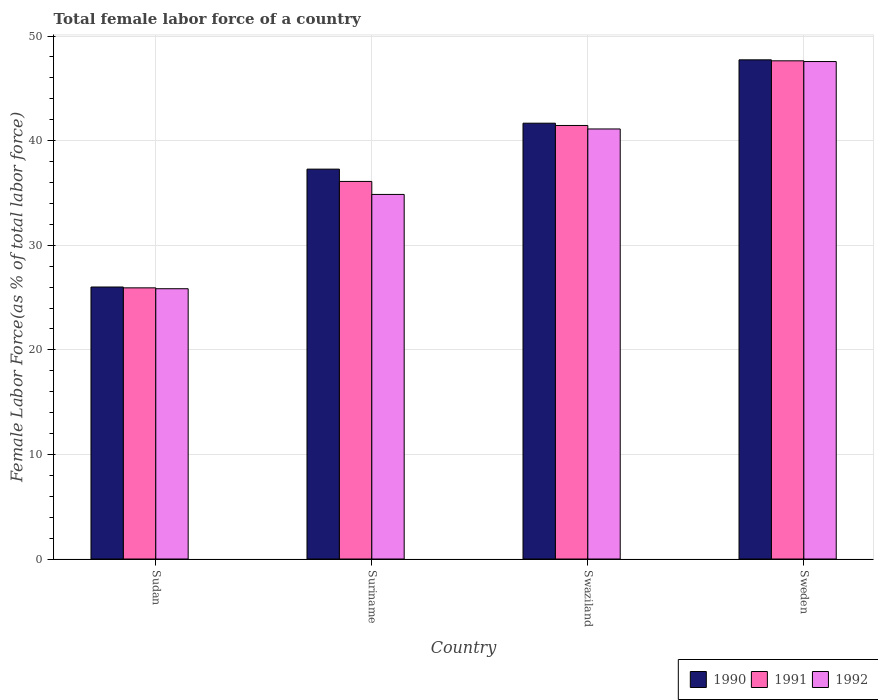How many different coloured bars are there?
Your answer should be very brief. 3. Are the number of bars per tick equal to the number of legend labels?
Your answer should be very brief. Yes. How many bars are there on the 4th tick from the right?
Provide a short and direct response. 3. In how many cases, is the number of bars for a given country not equal to the number of legend labels?
Make the answer very short. 0. What is the percentage of female labor force in 1991 in Swaziland?
Your answer should be compact. 41.45. Across all countries, what is the maximum percentage of female labor force in 1992?
Make the answer very short. 47.57. Across all countries, what is the minimum percentage of female labor force in 1990?
Give a very brief answer. 26.01. In which country was the percentage of female labor force in 1991 maximum?
Provide a short and direct response. Sweden. In which country was the percentage of female labor force in 1991 minimum?
Your answer should be compact. Sudan. What is the total percentage of female labor force in 1992 in the graph?
Your answer should be compact. 149.39. What is the difference between the percentage of female labor force in 1991 in Swaziland and that in Sweden?
Offer a terse response. -6.18. What is the difference between the percentage of female labor force in 1990 in Suriname and the percentage of female labor force in 1992 in Swaziland?
Give a very brief answer. -3.84. What is the average percentage of female labor force in 1990 per country?
Your answer should be compact. 38.17. What is the difference between the percentage of female labor force of/in 1991 and percentage of female labor force of/in 1990 in Swaziland?
Offer a very short reply. -0.22. In how many countries, is the percentage of female labor force in 1990 greater than 10 %?
Provide a succinct answer. 4. What is the ratio of the percentage of female labor force in 1991 in Suriname to that in Sweden?
Your answer should be compact. 0.76. What is the difference between the highest and the second highest percentage of female labor force in 1992?
Ensure brevity in your answer.  6.26. What is the difference between the highest and the lowest percentage of female labor force in 1991?
Ensure brevity in your answer.  21.71. Is the sum of the percentage of female labor force in 1992 in Sudan and Sweden greater than the maximum percentage of female labor force in 1990 across all countries?
Your answer should be compact. Yes. What does the 3rd bar from the left in Sudan represents?
Offer a very short reply. 1992. What does the 3rd bar from the right in Sudan represents?
Keep it short and to the point. 1990. How many bars are there?
Your answer should be very brief. 12. How many countries are there in the graph?
Offer a very short reply. 4. Are the values on the major ticks of Y-axis written in scientific E-notation?
Your answer should be compact. No. Does the graph contain any zero values?
Offer a very short reply. No. How are the legend labels stacked?
Offer a very short reply. Horizontal. What is the title of the graph?
Ensure brevity in your answer.  Total female labor force of a country. What is the label or title of the X-axis?
Your answer should be compact. Country. What is the label or title of the Y-axis?
Make the answer very short. Female Labor Force(as % of total labor force). What is the Female Labor Force(as % of total labor force) of 1990 in Sudan?
Your answer should be compact. 26.01. What is the Female Labor Force(as % of total labor force) in 1991 in Sudan?
Offer a terse response. 25.93. What is the Female Labor Force(as % of total labor force) in 1992 in Sudan?
Your answer should be compact. 25.84. What is the Female Labor Force(as % of total labor force) in 1990 in Suriname?
Your answer should be very brief. 37.28. What is the Female Labor Force(as % of total labor force) in 1991 in Suriname?
Provide a short and direct response. 36.1. What is the Female Labor Force(as % of total labor force) in 1992 in Suriname?
Ensure brevity in your answer.  34.86. What is the Female Labor Force(as % of total labor force) in 1990 in Swaziland?
Offer a terse response. 41.67. What is the Female Labor Force(as % of total labor force) in 1991 in Swaziland?
Provide a succinct answer. 41.45. What is the Female Labor Force(as % of total labor force) in 1992 in Swaziland?
Offer a very short reply. 41.12. What is the Female Labor Force(as % of total labor force) in 1990 in Sweden?
Your answer should be compact. 47.73. What is the Female Labor Force(as % of total labor force) in 1991 in Sweden?
Make the answer very short. 47.63. What is the Female Labor Force(as % of total labor force) of 1992 in Sweden?
Provide a short and direct response. 47.57. Across all countries, what is the maximum Female Labor Force(as % of total labor force) of 1990?
Your answer should be compact. 47.73. Across all countries, what is the maximum Female Labor Force(as % of total labor force) of 1991?
Provide a succinct answer. 47.63. Across all countries, what is the maximum Female Labor Force(as % of total labor force) in 1992?
Offer a terse response. 47.57. Across all countries, what is the minimum Female Labor Force(as % of total labor force) in 1990?
Your answer should be compact. 26.01. Across all countries, what is the minimum Female Labor Force(as % of total labor force) in 1991?
Your answer should be very brief. 25.93. Across all countries, what is the minimum Female Labor Force(as % of total labor force) of 1992?
Make the answer very short. 25.84. What is the total Female Labor Force(as % of total labor force) in 1990 in the graph?
Offer a terse response. 152.68. What is the total Female Labor Force(as % of total labor force) in 1991 in the graph?
Your response must be concise. 151.12. What is the total Female Labor Force(as % of total labor force) in 1992 in the graph?
Offer a terse response. 149.39. What is the difference between the Female Labor Force(as % of total labor force) of 1990 in Sudan and that in Suriname?
Make the answer very short. -11.27. What is the difference between the Female Labor Force(as % of total labor force) in 1991 in Sudan and that in Suriname?
Give a very brief answer. -10.17. What is the difference between the Female Labor Force(as % of total labor force) in 1992 in Sudan and that in Suriname?
Your answer should be compact. -9.02. What is the difference between the Female Labor Force(as % of total labor force) in 1990 in Sudan and that in Swaziland?
Provide a succinct answer. -15.66. What is the difference between the Female Labor Force(as % of total labor force) of 1991 in Sudan and that in Swaziland?
Keep it short and to the point. -15.53. What is the difference between the Female Labor Force(as % of total labor force) of 1992 in Sudan and that in Swaziland?
Give a very brief answer. -15.28. What is the difference between the Female Labor Force(as % of total labor force) of 1990 in Sudan and that in Sweden?
Offer a terse response. -21.72. What is the difference between the Female Labor Force(as % of total labor force) in 1991 in Sudan and that in Sweden?
Give a very brief answer. -21.71. What is the difference between the Female Labor Force(as % of total labor force) in 1992 in Sudan and that in Sweden?
Your response must be concise. -21.72. What is the difference between the Female Labor Force(as % of total labor force) of 1990 in Suriname and that in Swaziland?
Offer a terse response. -4.39. What is the difference between the Female Labor Force(as % of total labor force) of 1991 in Suriname and that in Swaziland?
Your response must be concise. -5.35. What is the difference between the Female Labor Force(as % of total labor force) of 1992 in Suriname and that in Swaziland?
Provide a short and direct response. -6.26. What is the difference between the Female Labor Force(as % of total labor force) in 1990 in Suriname and that in Sweden?
Ensure brevity in your answer.  -10.45. What is the difference between the Female Labor Force(as % of total labor force) in 1991 in Suriname and that in Sweden?
Give a very brief answer. -11.53. What is the difference between the Female Labor Force(as % of total labor force) in 1992 in Suriname and that in Sweden?
Offer a terse response. -12.71. What is the difference between the Female Labor Force(as % of total labor force) of 1990 in Swaziland and that in Sweden?
Provide a succinct answer. -6.06. What is the difference between the Female Labor Force(as % of total labor force) in 1991 in Swaziland and that in Sweden?
Your answer should be very brief. -6.18. What is the difference between the Female Labor Force(as % of total labor force) in 1992 in Swaziland and that in Sweden?
Your answer should be very brief. -6.45. What is the difference between the Female Labor Force(as % of total labor force) of 1990 in Sudan and the Female Labor Force(as % of total labor force) of 1991 in Suriname?
Offer a very short reply. -10.09. What is the difference between the Female Labor Force(as % of total labor force) in 1990 in Sudan and the Female Labor Force(as % of total labor force) in 1992 in Suriname?
Offer a terse response. -8.85. What is the difference between the Female Labor Force(as % of total labor force) in 1991 in Sudan and the Female Labor Force(as % of total labor force) in 1992 in Suriname?
Offer a terse response. -8.93. What is the difference between the Female Labor Force(as % of total labor force) of 1990 in Sudan and the Female Labor Force(as % of total labor force) of 1991 in Swaziland?
Provide a succinct answer. -15.45. What is the difference between the Female Labor Force(as % of total labor force) in 1990 in Sudan and the Female Labor Force(as % of total labor force) in 1992 in Swaziland?
Your answer should be very brief. -15.11. What is the difference between the Female Labor Force(as % of total labor force) in 1991 in Sudan and the Female Labor Force(as % of total labor force) in 1992 in Swaziland?
Your response must be concise. -15.19. What is the difference between the Female Labor Force(as % of total labor force) in 1990 in Sudan and the Female Labor Force(as % of total labor force) in 1991 in Sweden?
Keep it short and to the point. -21.63. What is the difference between the Female Labor Force(as % of total labor force) of 1990 in Sudan and the Female Labor Force(as % of total labor force) of 1992 in Sweden?
Offer a very short reply. -21.56. What is the difference between the Female Labor Force(as % of total labor force) in 1991 in Sudan and the Female Labor Force(as % of total labor force) in 1992 in Sweden?
Your response must be concise. -21.64. What is the difference between the Female Labor Force(as % of total labor force) in 1990 in Suriname and the Female Labor Force(as % of total labor force) in 1991 in Swaziland?
Ensure brevity in your answer.  -4.17. What is the difference between the Female Labor Force(as % of total labor force) in 1990 in Suriname and the Female Labor Force(as % of total labor force) in 1992 in Swaziland?
Keep it short and to the point. -3.84. What is the difference between the Female Labor Force(as % of total labor force) in 1991 in Suriname and the Female Labor Force(as % of total labor force) in 1992 in Swaziland?
Offer a very short reply. -5.02. What is the difference between the Female Labor Force(as % of total labor force) in 1990 in Suriname and the Female Labor Force(as % of total labor force) in 1991 in Sweden?
Offer a very short reply. -10.36. What is the difference between the Female Labor Force(as % of total labor force) of 1990 in Suriname and the Female Labor Force(as % of total labor force) of 1992 in Sweden?
Your response must be concise. -10.29. What is the difference between the Female Labor Force(as % of total labor force) in 1991 in Suriname and the Female Labor Force(as % of total labor force) in 1992 in Sweden?
Ensure brevity in your answer.  -11.46. What is the difference between the Female Labor Force(as % of total labor force) of 1990 in Swaziland and the Female Labor Force(as % of total labor force) of 1991 in Sweden?
Keep it short and to the point. -5.96. What is the difference between the Female Labor Force(as % of total labor force) of 1990 in Swaziland and the Female Labor Force(as % of total labor force) of 1992 in Sweden?
Provide a succinct answer. -5.9. What is the difference between the Female Labor Force(as % of total labor force) of 1991 in Swaziland and the Female Labor Force(as % of total labor force) of 1992 in Sweden?
Your response must be concise. -6.11. What is the average Female Labor Force(as % of total labor force) of 1990 per country?
Ensure brevity in your answer.  38.17. What is the average Female Labor Force(as % of total labor force) in 1991 per country?
Keep it short and to the point. 37.78. What is the average Female Labor Force(as % of total labor force) in 1992 per country?
Provide a short and direct response. 37.35. What is the difference between the Female Labor Force(as % of total labor force) in 1990 and Female Labor Force(as % of total labor force) in 1992 in Sudan?
Offer a very short reply. 0.16. What is the difference between the Female Labor Force(as % of total labor force) in 1991 and Female Labor Force(as % of total labor force) in 1992 in Sudan?
Your answer should be very brief. 0.08. What is the difference between the Female Labor Force(as % of total labor force) in 1990 and Female Labor Force(as % of total labor force) in 1991 in Suriname?
Ensure brevity in your answer.  1.18. What is the difference between the Female Labor Force(as % of total labor force) in 1990 and Female Labor Force(as % of total labor force) in 1992 in Suriname?
Offer a very short reply. 2.42. What is the difference between the Female Labor Force(as % of total labor force) in 1991 and Female Labor Force(as % of total labor force) in 1992 in Suriname?
Your answer should be compact. 1.24. What is the difference between the Female Labor Force(as % of total labor force) of 1990 and Female Labor Force(as % of total labor force) of 1991 in Swaziland?
Provide a succinct answer. 0.22. What is the difference between the Female Labor Force(as % of total labor force) of 1990 and Female Labor Force(as % of total labor force) of 1992 in Swaziland?
Ensure brevity in your answer.  0.55. What is the difference between the Female Labor Force(as % of total labor force) in 1991 and Female Labor Force(as % of total labor force) in 1992 in Swaziland?
Your answer should be very brief. 0.33. What is the difference between the Female Labor Force(as % of total labor force) in 1990 and Female Labor Force(as % of total labor force) in 1991 in Sweden?
Provide a succinct answer. 0.09. What is the difference between the Female Labor Force(as % of total labor force) of 1990 and Female Labor Force(as % of total labor force) of 1992 in Sweden?
Offer a very short reply. 0.16. What is the difference between the Female Labor Force(as % of total labor force) of 1991 and Female Labor Force(as % of total labor force) of 1992 in Sweden?
Your response must be concise. 0.07. What is the ratio of the Female Labor Force(as % of total labor force) in 1990 in Sudan to that in Suriname?
Offer a terse response. 0.7. What is the ratio of the Female Labor Force(as % of total labor force) in 1991 in Sudan to that in Suriname?
Provide a short and direct response. 0.72. What is the ratio of the Female Labor Force(as % of total labor force) of 1992 in Sudan to that in Suriname?
Offer a terse response. 0.74. What is the ratio of the Female Labor Force(as % of total labor force) in 1990 in Sudan to that in Swaziland?
Your answer should be compact. 0.62. What is the ratio of the Female Labor Force(as % of total labor force) in 1991 in Sudan to that in Swaziland?
Make the answer very short. 0.63. What is the ratio of the Female Labor Force(as % of total labor force) in 1992 in Sudan to that in Swaziland?
Provide a short and direct response. 0.63. What is the ratio of the Female Labor Force(as % of total labor force) in 1990 in Sudan to that in Sweden?
Offer a very short reply. 0.54. What is the ratio of the Female Labor Force(as % of total labor force) of 1991 in Sudan to that in Sweden?
Provide a succinct answer. 0.54. What is the ratio of the Female Labor Force(as % of total labor force) in 1992 in Sudan to that in Sweden?
Your answer should be compact. 0.54. What is the ratio of the Female Labor Force(as % of total labor force) of 1990 in Suriname to that in Swaziland?
Your answer should be very brief. 0.89. What is the ratio of the Female Labor Force(as % of total labor force) of 1991 in Suriname to that in Swaziland?
Make the answer very short. 0.87. What is the ratio of the Female Labor Force(as % of total labor force) in 1992 in Suriname to that in Swaziland?
Your answer should be compact. 0.85. What is the ratio of the Female Labor Force(as % of total labor force) in 1990 in Suriname to that in Sweden?
Your answer should be compact. 0.78. What is the ratio of the Female Labor Force(as % of total labor force) in 1991 in Suriname to that in Sweden?
Offer a terse response. 0.76. What is the ratio of the Female Labor Force(as % of total labor force) of 1992 in Suriname to that in Sweden?
Ensure brevity in your answer.  0.73. What is the ratio of the Female Labor Force(as % of total labor force) in 1990 in Swaziland to that in Sweden?
Keep it short and to the point. 0.87. What is the ratio of the Female Labor Force(as % of total labor force) of 1991 in Swaziland to that in Sweden?
Provide a succinct answer. 0.87. What is the ratio of the Female Labor Force(as % of total labor force) in 1992 in Swaziland to that in Sweden?
Your response must be concise. 0.86. What is the difference between the highest and the second highest Female Labor Force(as % of total labor force) of 1990?
Keep it short and to the point. 6.06. What is the difference between the highest and the second highest Female Labor Force(as % of total labor force) in 1991?
Your response must be concise. 6.18. What is the difference between the highest and the second highest Female Labor Force(as % of total labor force) in 1992?
Your answer should be very brief. 6.45. What is the difference between the highest and the lowest Female Labor Force(as % of total labor force) in 1990?
Keep it short and to the point. 21.72. What is the difference between the highest and the lowest Female Labor Force(as % of total labor force) in 1991?
Offer a very short reply. 21.71. What is the difference between the highest and the lowest Female Labor Force(as % of total labor force) of 1992?
Offer a terse response. 21.72. 